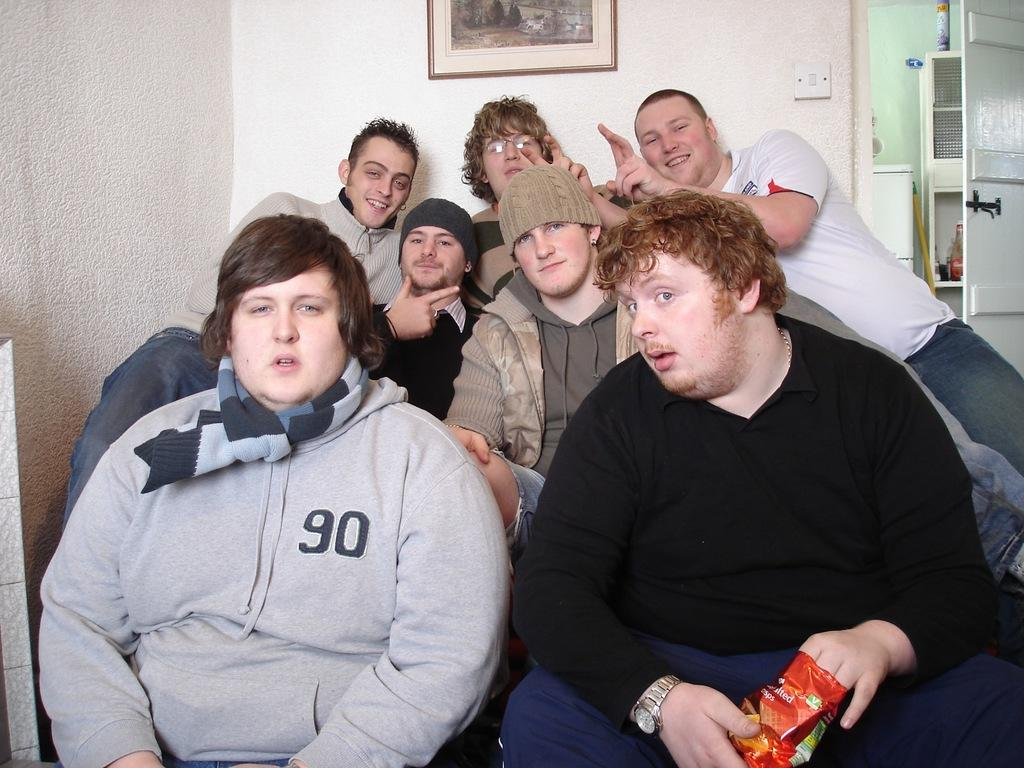How many men are in the foreground of the image? There are seven men in the foreground of the image. What are the men doing in the image? The men are sitting and posing for a camera. What can be seen in the background of the image? There is a wall, a frame, a door, a stick, and a cupboard in the background of the image. What type of glass is being used to control the men in the image? There is no glass or control mechanism present in the image; the men are simply sitting and posing for a camera. What kind of coach is visible in the background of the image? There is no coach present in the image; the background elements include a wall, a frame, a door, a stick, and a cupboard. 